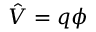Convert formula to latex. <formula><loc_0><loc_0><loc_500><loc_500>{ \hat { V } } = q \phi</formula> 